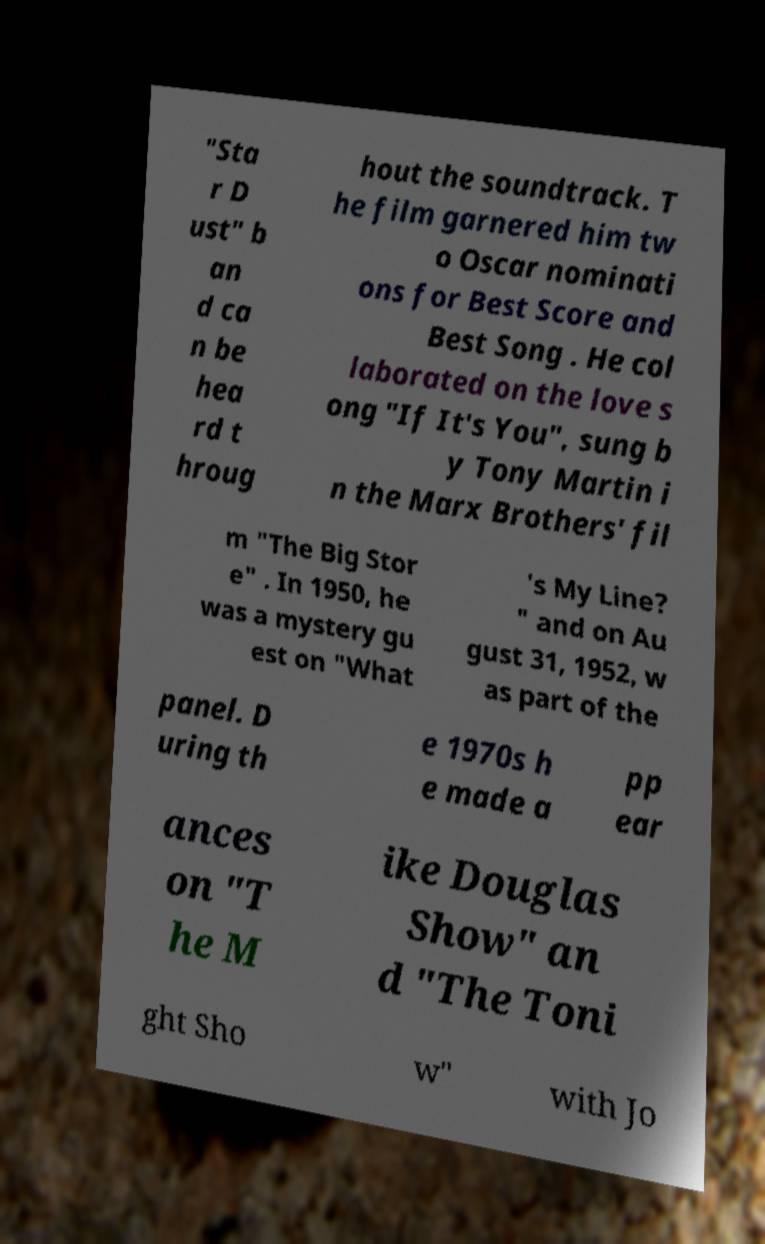Please identify and transcribe the text found in this image. "Sta r D ust" b an d ca n be hea rd t hroug hout the soundtrack. T he film garnered him tw o Oscar nominati ons for Best Score and Best Song . He col laborated on the love s ong "If It's You", sung b y Tony Martin i n the Marx Brothers' fil m "The Big Stor e" . In 1950, he was a mystery gu est on "What 's My Line? " and on Au gust 31, 1952, w as part of the panel. D uring th e 1970s h e made a pp ear ances on "T he M ike Douglas Show" an d "The Toni ght Sho w" with Jo 